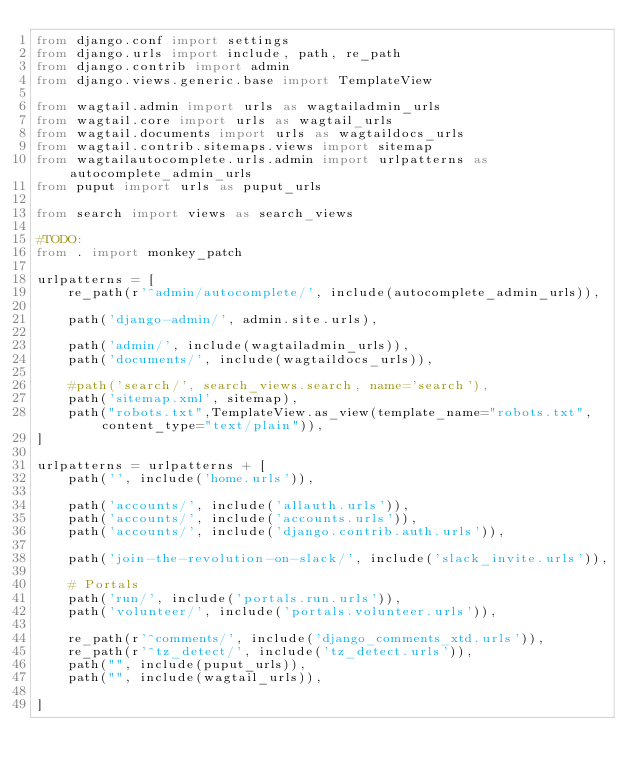<code> <loc_0><loc_0><loc_500><loc_500><_Python_>from django.conf import settings
from django.urls import include, path, re_path
from django.contrib import admin
from django.views.generic.base import TemplateView

from wagtail.admin import urls as wagtailadmin_urls
from wagtail.core import urls as wagtail_urls
from wagtail.documents import urls as wagtaildocs_urls
from wagtail.contrib.sitemaps.views import sitemap
from wagtailautocomplete.urls.admin import urlpatterns as autocomplete_admin_urls
from puput import urls as puput_urls

from search import views as search_views

#TODO:
from . import monkey_patch

urlpatterns = [
    re_path(r'^admin/autocomplete/', include(autocomplete_admin_urls)),

    path('django-admin/', admin.site.urls),

    path('admin/', include(wagtailadmin_urls)),
    path('documents/', include(wagtaildocs_urls)),

    #path('search/', search_views.search, name='search'),
    path('sitemap.xml', sitemap),
    path("robots.txt",TemplateView.as_view(template_name="robots.txt", content_type="text/plain")),
]

urlpatterns = urlpatterns + [
    path('', include('home.urls')),

    path('accounts/', include('allauth.urls')),
    path('accounts/', include('accounts.urls')),
    path('accounts/', include('django.contrib.auth.urls')),

    path('join-the-revolution-on-slack/', include('slack_invite.urls')),

    # Portals
    path('run/', include('portals.run.urls')),
    path('volunteer/', include('portals.volunteer.urls')),

    re_path(r'^comments/', include('django_comments_xtd.urls')),
    re_path(r'^tz_detect/', include('tz_detect.urls')),
    path("", include(puput_urls)),
    path("", include(wagtail_urls)),

]</code> 